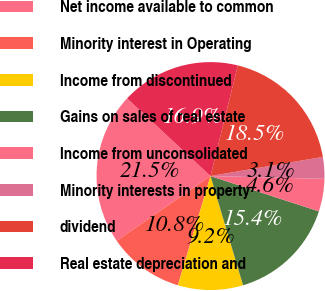Convert chart to OTSL. <chart><loc_0><loc_0><loc_500><loc_500><pie_chart><fcel>Net income available to common<fcel>Minority interest in Operating<fcel>Income from discontinued<fcel>Gains on sales of real estate<fcel>Income from unconsolidated<fcel>Minority interests in property<fcel>dividend<fcel>Real estate depreciation and<nl><fcel>21.54%<fcel>10.77%<fcel>9.23%<fcel>15.38%<fcel>4.62%<fcel>3.08%<fcel>18.46%<fcel>16.92%<nl></chart> 